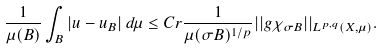<formula> <loc_0><loc_0><loc_500><loc_500>\frac { 1 } { \mu ( B ) } \int _ { B } | u - u _ { B } | \, d \mu \leq C r \frac { 1 } { \mu ( \sigma B ) ^ { 1 / p } } | | g \chi _ { \sigma B } | | _ { L ^ { p , q } ( X , \mu ) } .</formula> 